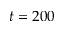Convert formula to latex. <formula><loc_0><loc_0><loc_500><loc_500>t = 2 0 0</formula> 